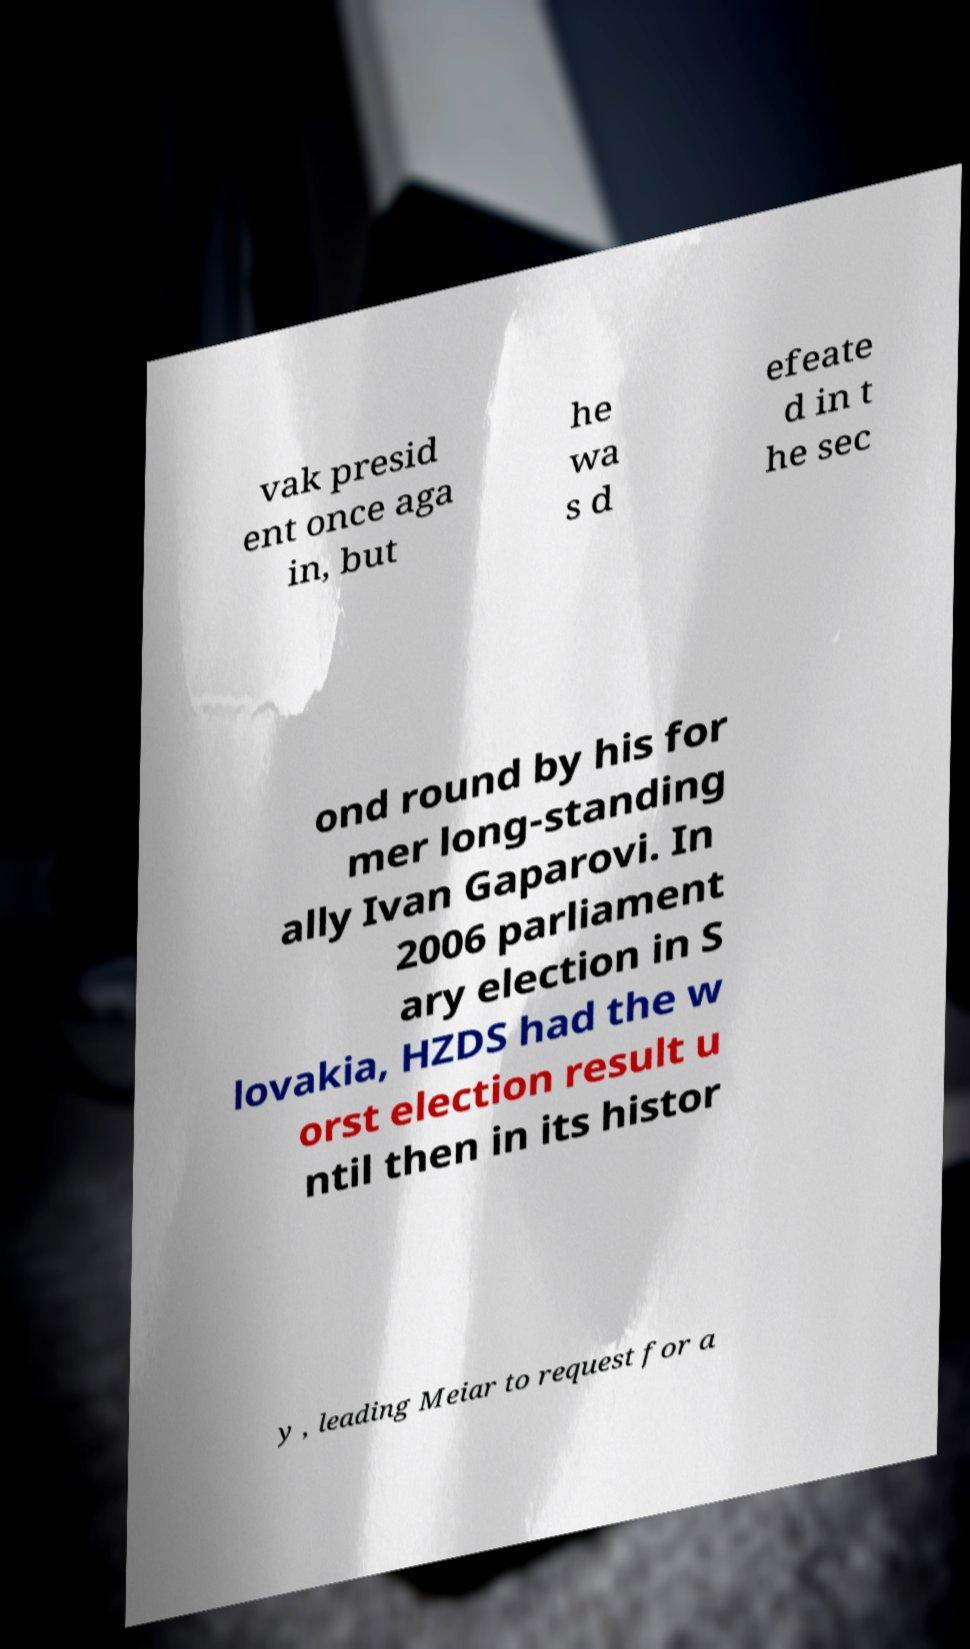I need the written content from this picture converted into text. Can you do that? vak presid ent once aga in, but he wa s d efeate d in t he sec ond round by his for mer long-standing ally Ivan Gaparovi. In 2006 parliament ary election in S lovakia, HZDS had the w orst election result u ntil then in its histor y , leading Meiar to request for a 